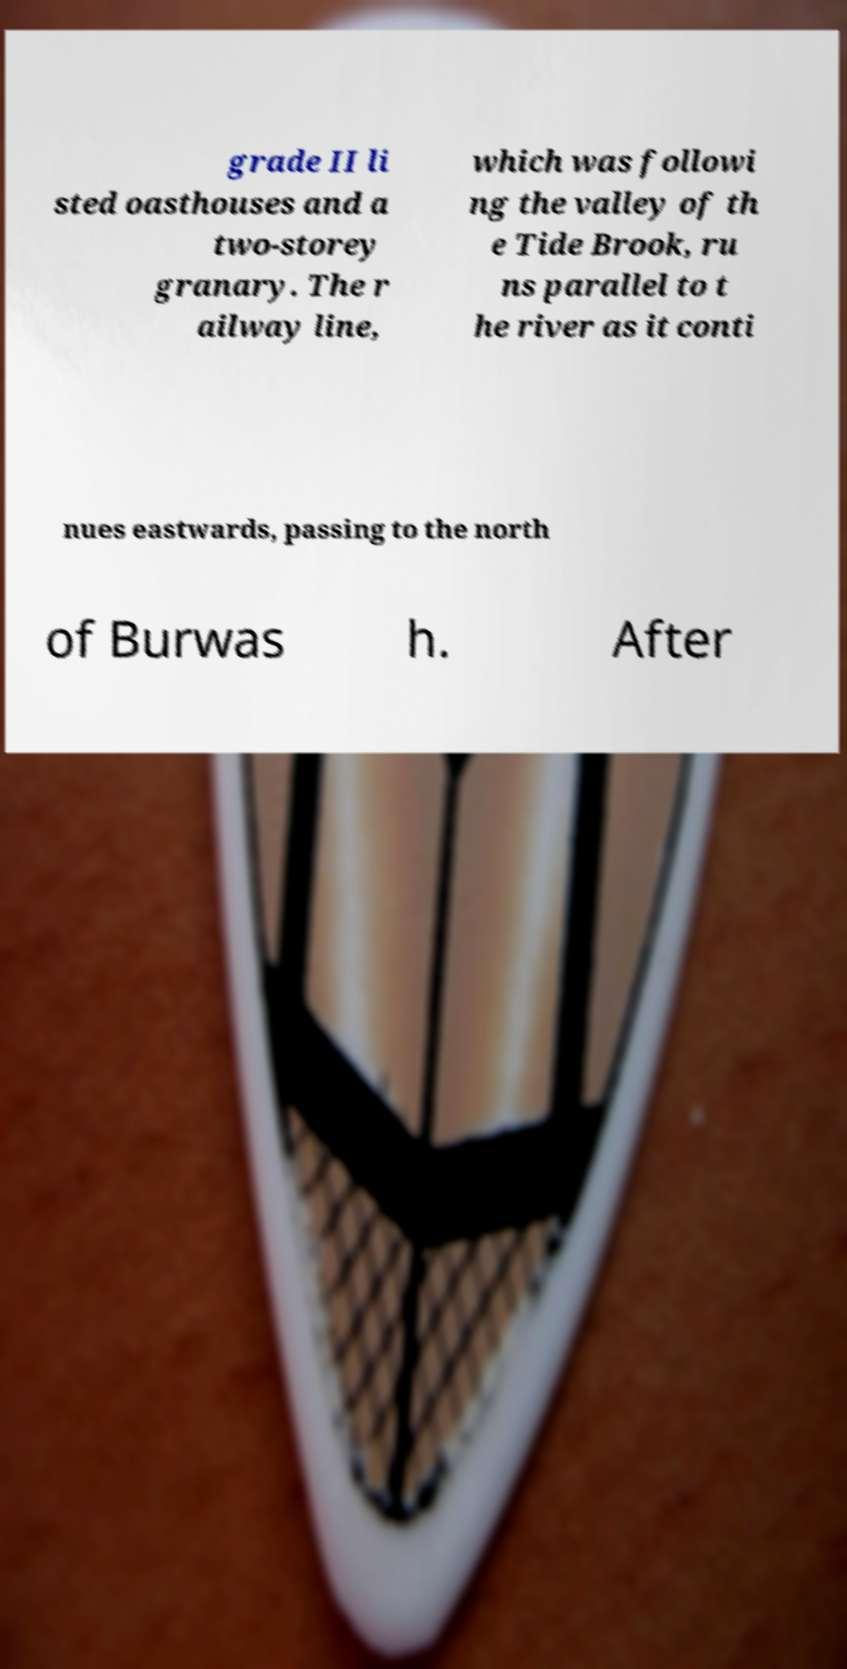Please read and relay the text visible in this image. What does it say? grade II li sted oasthouses and a two-storey granary. The r ailway line, which was followi ng the valley of th e Tide Brook, ru ns parallel to t he river as it conti nues eastwards, passing to the north of Burwas h. After 